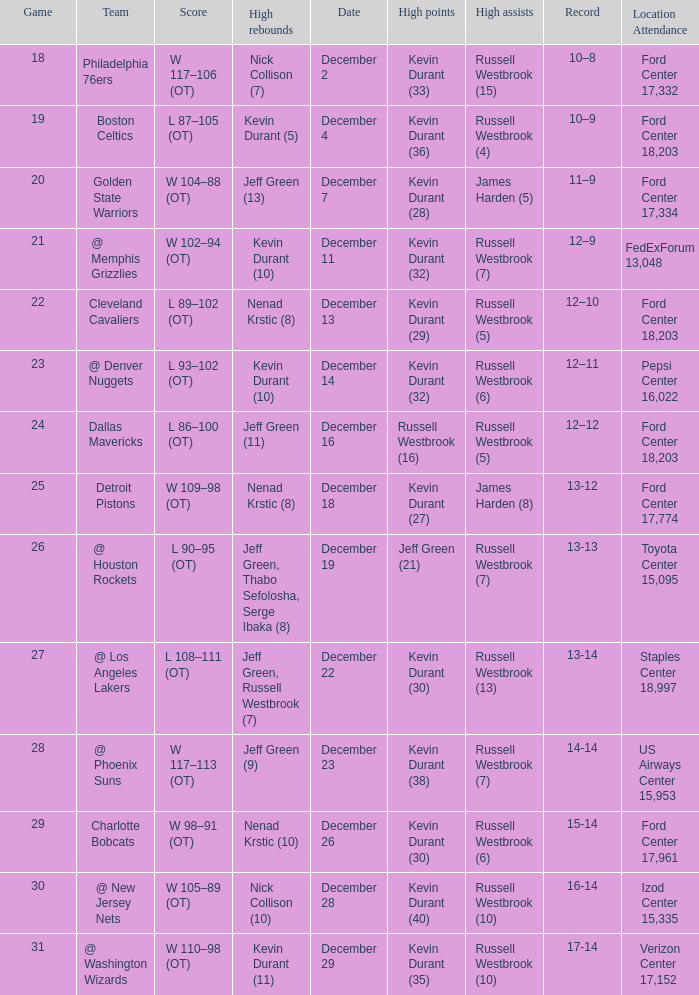What is the score for the date of December 7? W 104–88 (OT). 